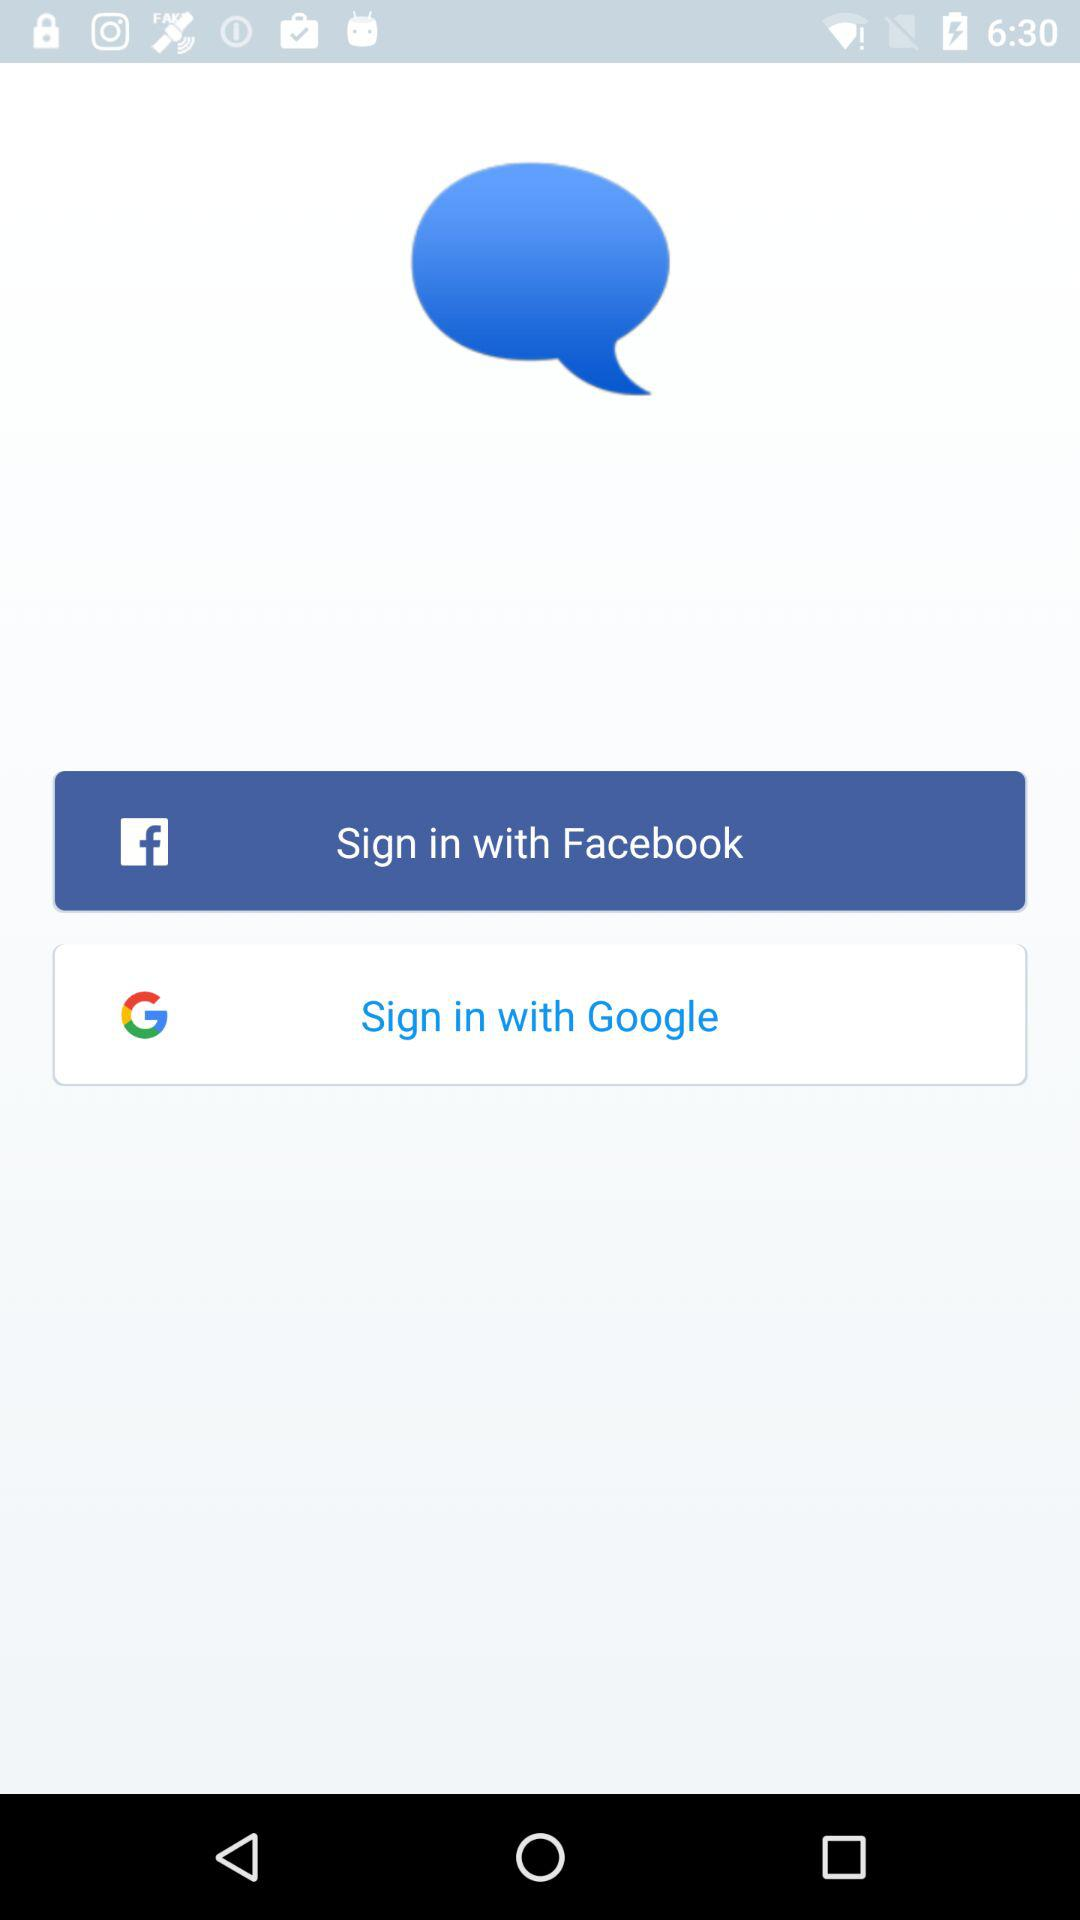What are the different options available to sign in? The different options available to sign in are "Facebook" and "Google". 